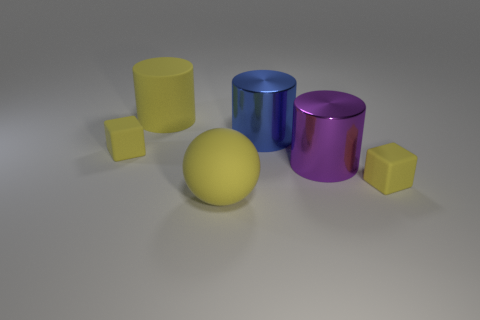Is there a pattern to the arrangement of objects? The objects are arranged without a clear pattern. They are placed in a somewhat scattered fashion, with varying distances between them, likely for display or demonstration purposes. 